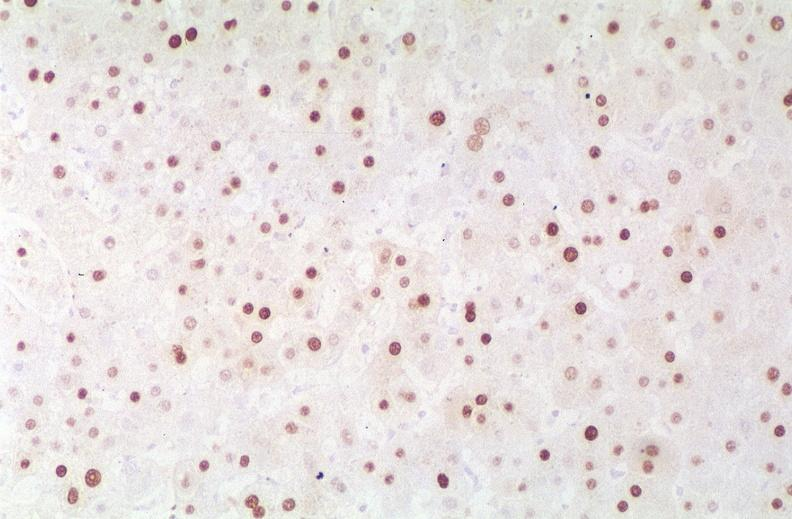s hepatobiliary present?
Answer the question using a single word or phrase. Yes 